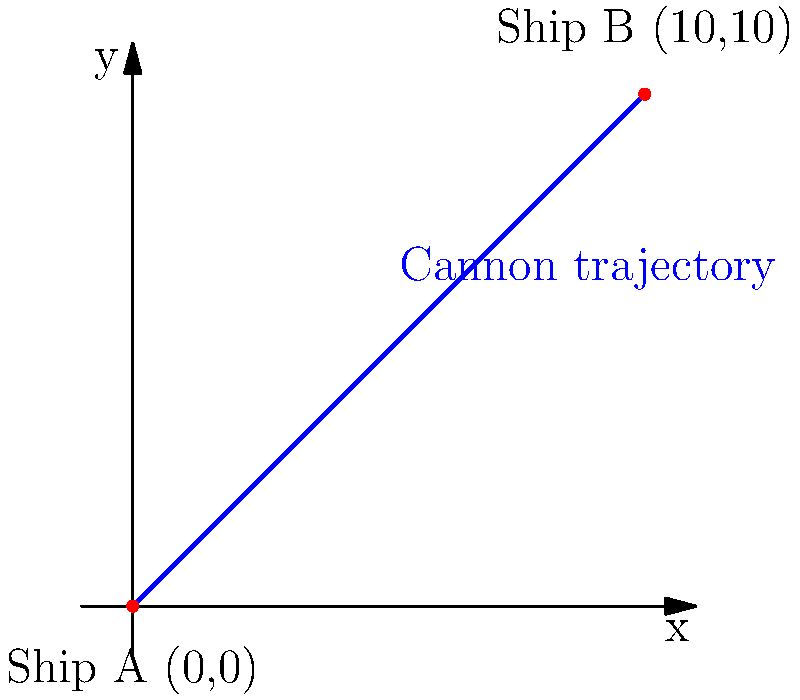During a fierce battle at sea, your ship (Ship A) is positioned at coordinates (0,0), and an enemy vessel (Ship B) is spotted at coordinates (10,10). You aim to fire a cannon shot that follows a straight trajectory between the two ships. What is the slope of the line representing the cannon shot's trajectory? To find the slope of the line representing the cannon shot's trajectory, we can use the slope formula:

$$ m = \frac{y_2 - y_1}{x_2 - x_1} $$

Where $(x_1, y_1)$ represents the coordinates of Ship A, and $(x_2, y_2)$ represents the coordinates of Ship B.

Given:
- Ship A is at (0,0), so $x_1 = 0$ and $y_1 = 0$
- Ship B is at (10,10), so $x_2 = 10$ and $y_2 = 10$

Let's plug these values into the slope formula:

$$ m = \frac{10 - 0}{10 - 0} = \frac{10}{10} = 1 $$

Therefore, the slope of the line representing the cannon shot's trajectory is 1.

This means that for every unit increase in x, y also increases by 1 unit, resulting in a 45-degree angle trajectory.
Answer: 1 